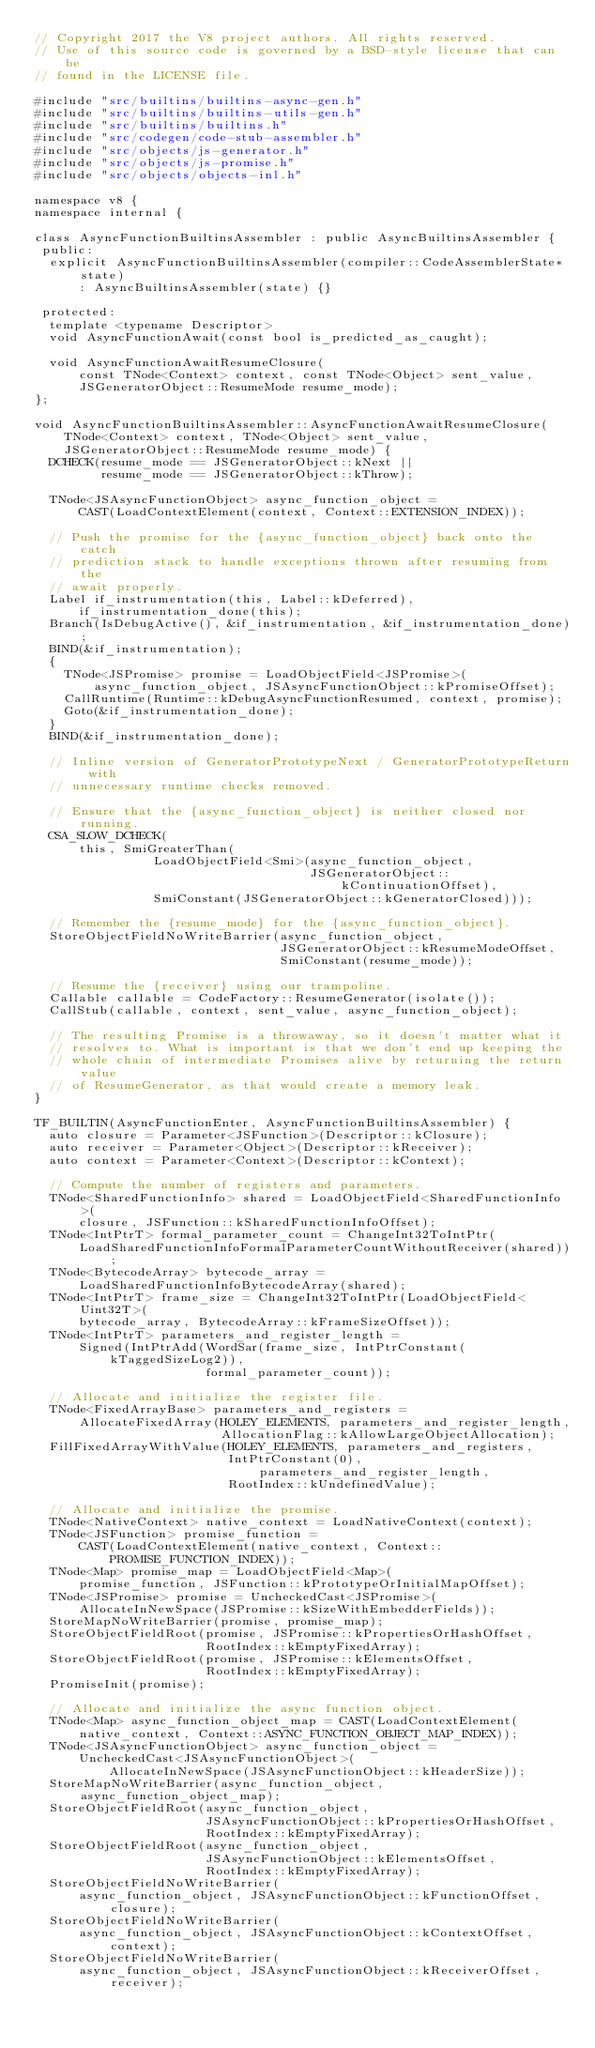Convert code to text. <code><loc_0><loc_0><loc_500><loc_500><_C++_>// Copyright 2017 the V8 project authors. All rights reserved.
// Use of this source code is governed by a BSD-style license that can be
// found in the LICENSE file.

#include "src/builtins/builtins-async-gen.h"
#include "src/builtins/builtins-utils-gen.h"
#include "src/builtins/builtins.h"
#include "src/codegen/code-stub-assembler.h"
#include "src/objects/js-generator.h"
#include "src/objects/js-promise.h"
#include "src/objects/objects-inl.h"

namespace v8 {
namespace internal {

class AsyncFunctionBuiltinsAssembler : public AsyncBuiltinsAssembler {
 public:
  explicit AsyncFunctionBuiltinsAssembler(compiler::CodeAssemblerState* state)
      : AsyncBuiltinsAssembler(state) {}

 protected:
  template <typename Descriptor>
  void AsyncFunctionAwait(const bool is_predicted_as_caught);

  void AsyncFunctionAwaitResumeClosure(
      const TNode<Context> context, const TNode<Object> sent_value,
      JSGeneratorObject::ResumeMode resume_mode);
};

void AsyncFunctionBuiltinsAssembler::AsyncFunctionAwaitResumeClosure(
    TNode<Context> context, TNode<Object> sent_value,
    JSGeneratorObject::ResumeMode resume_mode) {
  DCHECK(resume_mode == JSGeneratorObject::kNext ||
         resume_mode == JSGeneratorObject::kThrow);

  TNode<JSAsyncFunctionObject> async_function_object =
      CAST(LoadContextElement(context, Context::EXTENSION_INDEX));

  // Push the promise for the {async_function_object} back onto the catch
  // prediction stack to handle exceptions thrown after resuming from the
  // await properly.
  Label if_instrumentation(this, Label::kDeferred),
      if_instrumentation_done(this);
  Branch(IsDebugActive(), &if_instrumentation, &if_instrumentation_done);
  BIND(&if_instrumentation);
  {
    TNode<JSPromise> promise = LoadObjectField<JSPromise>(
        async_function_object, JSAsyncFunctionObject::kPromiseOffset);
    CallRuntime(Runtime::kDebugAsyncFunctionResumed, context, promise);
    Goto(&if_instrumentation_done);
  }
  BIND(&if_instrumentation_done);

  // Inline version of GeneratorPrototypeNext / GeneratorPrototypeReturn with
  // unnecessary runtime checks removed.

  // Ensure that the {async_function_object} is neither closed nor running.
  CSA_SLOW_DCHECK(
      this, SmiGreaterThan(
                LoadObjectField<Smi>(async_function_object,
                                     JSGeneratorObject::kContinuationOffset),
                SmiConstant(JSGeneratorObject::kGeneratorClosed)));

  // Remember the {resume_mode} for the {async_function_object}.
  StoreObjectFieldNoWriteBarrier(async_function_object,
                                 JSGeneratorObject::kResumeModeOffset,
                                 SmiConstant(resume_mode));

  // Resume the {receiver} using our trampoline.
  Callable callable = CodeFactory::ResumeGenerator(isolate());
  CallStub(callable, context, sent_value, async_function_object);

  // The resulting Promise is a throwaway, so it doesn't matter what it
  // resolves to. What is important is that we don't end up keeping the
  // whole chain of intermediate Promises alive by returning the return value
  // of ResumeGenerator, as that would create a memory leak.
}

TF_BUILTIN(AsyncFunctionEnter, AsyncFunctionBuiltinsAssembler) {
  auto closure = Parameter<JSFunction>(Descriptor::kClosure);
  auto receiver = Parameter<Object>(Descriptor::kReceiver);
  auto context = Parameter<Context>(Descriptor::kContext);

  // Compute the number of registers and parameters.
  TNode<SharedFunctionInfo> shared = LoadObjectField<SharedFunctionInfo>(
      closure, JSFunction::kSharedFunctionInfoOffset);
  TNode<IntPtrT> formal_parameter_count = ChangeInt32ToIntPtr(
      LoadSharedFunctionInfoFormalParameterCountWithoutReceiver(shared));
  TNode<BytecodeArray> bytecode_array =
      LoadSharedFunctionInfoBytecodeArray(shared);
  TNode<IntPtrT> frame_size = ChangeInt32ToIntPtr(LoadObjectField<Uint32T>(
      bytecode_array, BytecodeArray::kFrameSizeOffset));
  TNode<IntPtrT> parameters_and_register_length =
      Signed(IntPtrAdd(WordSar(frame_size, IntPtrConstant(kTaggedSizeLog2)),
                       formal_parameter_count));

  // Allocate and initialize the register file.
  TNode<FixedArrayBase> parameters_and_registers =
      AllocateFixedArray(HOLEY_ELEMENTS, parameters_and_register_length,
                         AllocationFlag::kAllowLargeObjectAllocation);
  FillFixedArrayWithValue(HOLEY_ELEMENTS, parameters_and_registers,
                          IntPtrConstant(0), parameters_and_register_length,
                          RootIndex::kUndefinedValue);

  // Allocate and initialize the promise.
  TNode<NativeContext> native_context = LoadNativeContext(context);
  TNode<JSFunction> promise_function =
      CAST(LoadContextElement(native_context, Context::PROMISE_FUNCTION_INDEX));
  TNode<Map> promise_map = LoadObjectField<Map>(
      promise_function, JSFunction::kPrototypeOrInitialMapOffset);
  TNode<JSPromise> promise = UncheckedCast<JSPromise>(
      AllocateInNewSpace(JSPromise::kSizeWithEmbedderFields));
  StoreMapNoWriteBarrier(promise, promise_map);
  StoreObjectFieldRoot(promise, JSPromise::kPropertiesOrHashOffset,
                       RootIndex::kEmptyFixedArray);
  StoreObjectFieldRoot(promise, JSPromise::kElementsOffset,
                       RootIndex::kEmptyFixedArray);
  PromiseInit(promise);

  // Allocate and initialize the async function object.
  TNode<Map> async_function_object_map = CAST(LoadContextElement(
      native_context, Context::ASYNC_FUNCTION_OBJECT_MAP_INDEX));
  TNode<JSAsyncFunctionObject> async_function_object =
      UncheckedCast<JSAsyncFunctionObject>(
          AllocateInNewSpace(JSAsyncFunctionObject::kHeaderSize));
  StoreMapNoWriteBarrier(async_function_object, async_function_object_map);
  StoreObjectFieldRoot(async_function_object,
                       JSAsyncFunctionObject::kPropertiesOrHashOffset,
                       RootIndex::kEmptyFixedArray);
  StoreObjectFieldRoot(async_function_object,
                       JSAsyncFunctionObject::kElementsOffset,
                       RootIndex::kEmptyFixedArray);
  StoreObjectFieldNoWriteBarrier(
      async_function_object, JSAsyncFunctionObject::kFunctionOffset, closure);
  StoreObjectFieldNoWriteBarrier(
      async_function_object, JSAsyncFunctionObject::kContextOffset, context);
  StoreObjectFieldNoWriteBarrier(
      async_function_object, JSAsyncFunctionObject::kReceiverOffset, receiver);</code> 